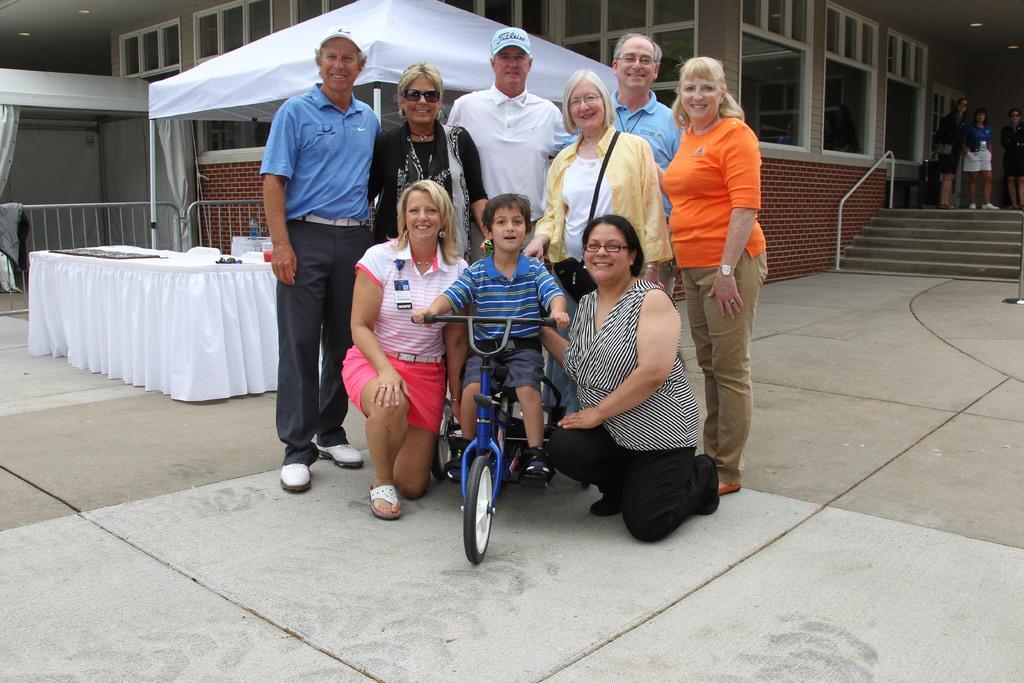Please provide a concise description of this image. In this picture we can see a group of people and a boy sitting on the bicycle. We can see a few objects on the table. There is a brick wall, a building, barricades, some lights, stairs and some objects. 